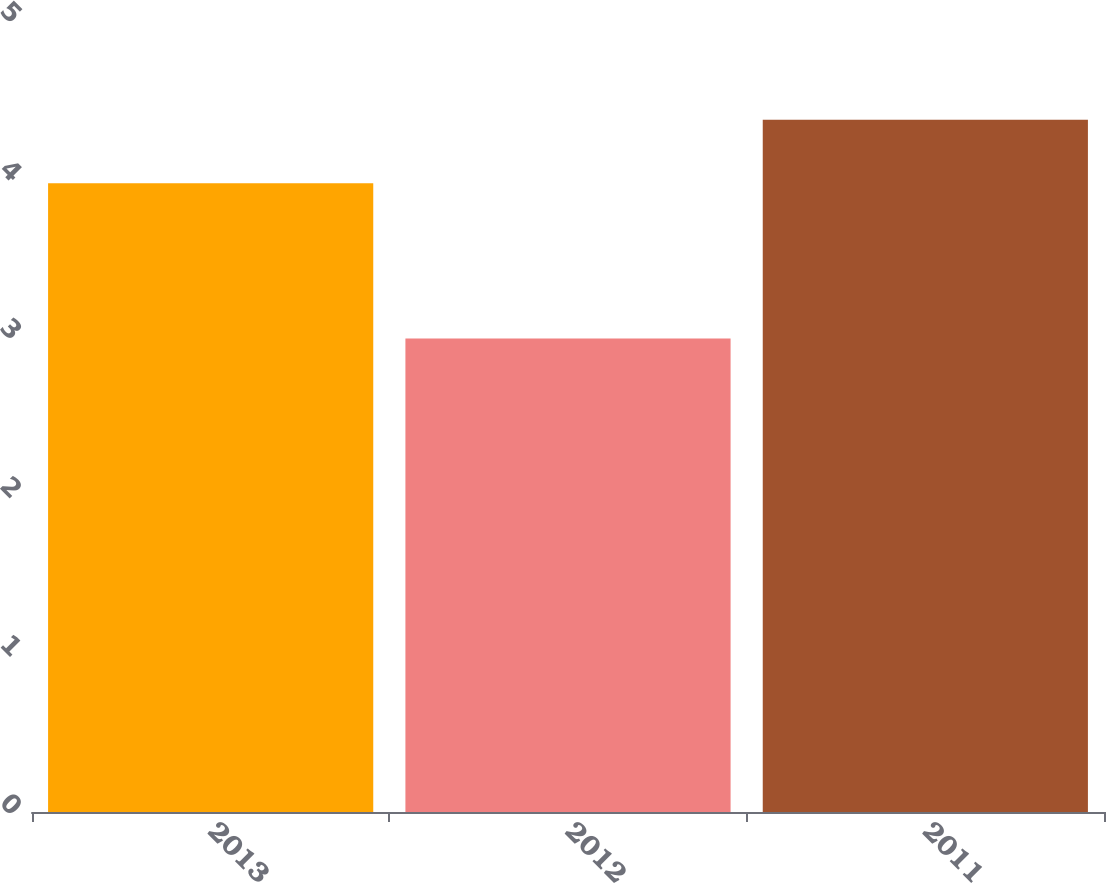Convert chart to OTSL. <chart><loc_0><loc_0><loc_500><loc_500><bar_chart><fcel>2013<fcel>2012<fcel>2011<nl><fcel>3.97<fcel>2.99<fcel>4.37<nl></chart> 